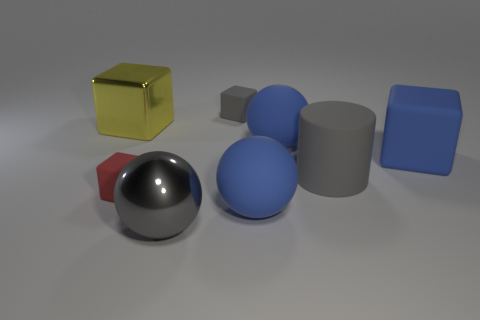Subtract all gray cylinders. How many blue balls are left? 2 Subtract all big gray spheres. How many spheres are left? 2 Add 1 tiny yellow rubber spheres. How many objects exist? 9 Subtract 1 blocks. How many blocks are left? 3 Subtract all blue blocks. How many blocks are left? 3 Subtract all spheres. How many objects are left? 5 Subtract all yellow blocks. Subtract all green cylinders. How many blocks are left? 3 Subtract all big matte balls. Subtract all red objects. How many objects are left? 5 Add 3 gray metal things. How many gray metal things are left? 4 Add 4 large purple spheres. How many large purple spheres exist? 4 